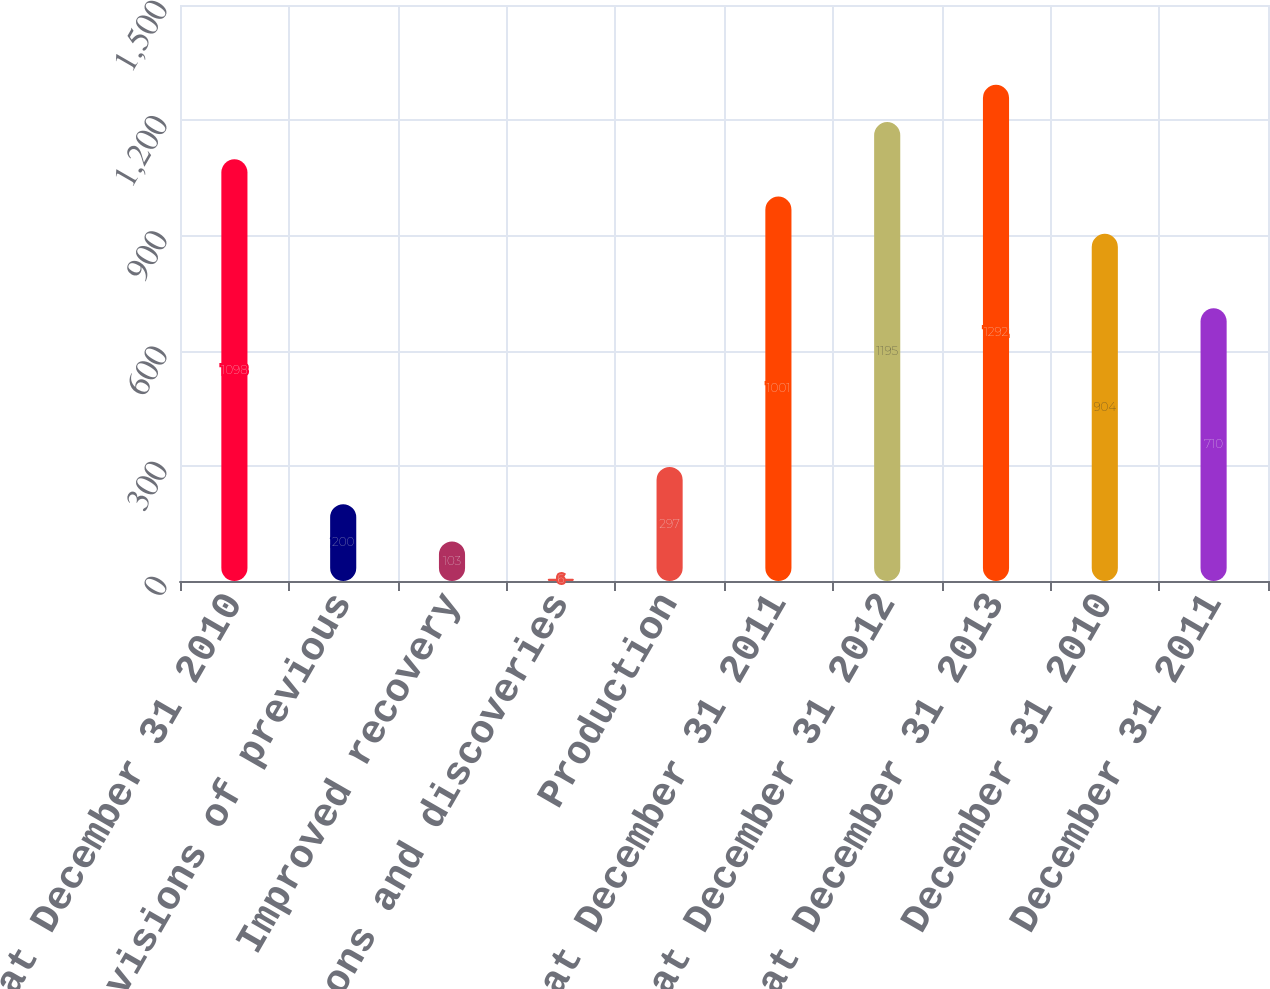Convert chart to OTSL. <chart><loc_0><loc_0><loc_500><loc_500><bar_chart><fcel>Balance at December 31 2010<fcel>Revisions of previous<fcel>Improved recovery<fcel>Extensions and discoveries<fcel>Production<fcel>Balance at December 31 2011<fcel>Balance at December 31 2012<fcel>Balance at December 31 2013<fcel>December 31 2010<fcel>December 31 2011<nl><fcel>1098<fcel>200<fcel>103<fcel>6<fcel>297<fcel>1001<fcel>1195<fcel>1292<fcel>904<fcel>710<nl></chart> 